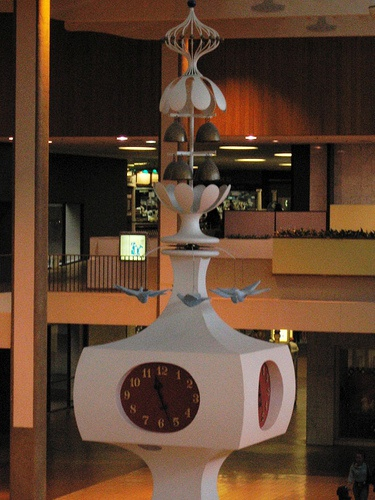Describe the objects in this image and their specific colors. I can see clock in maroon, black, and brown tones, people in black, maroon, and purple tones, clock in maroon, black, and brown tones, bird in maroon and gray tones, and bird in maroon, gray, and black tones in this image. 